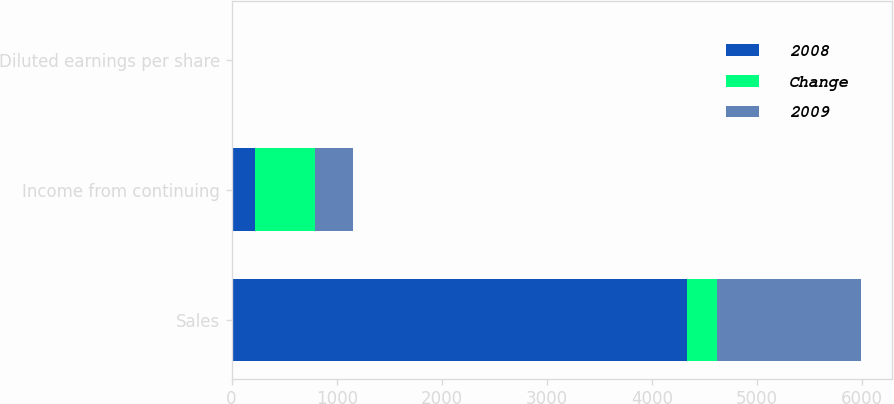Convert chart to OTSL. <chart><loc_0><loc_0><loc_500><loc_500><stacked_bar_chart><ecel><fcel>Sales<fcel>Income from continuing<fcel>Diluted earnings per share<nl><fcel>2008<fcel>4332.5<fcel>217.9<fcel>1.53<nl><fcel>Change<fcel>288.8<fcel>577.6<fcel>3.89<nl><fcel>2009<fcel>1365.3<fcel>359.7<fcel>2.36<nl></chart> 